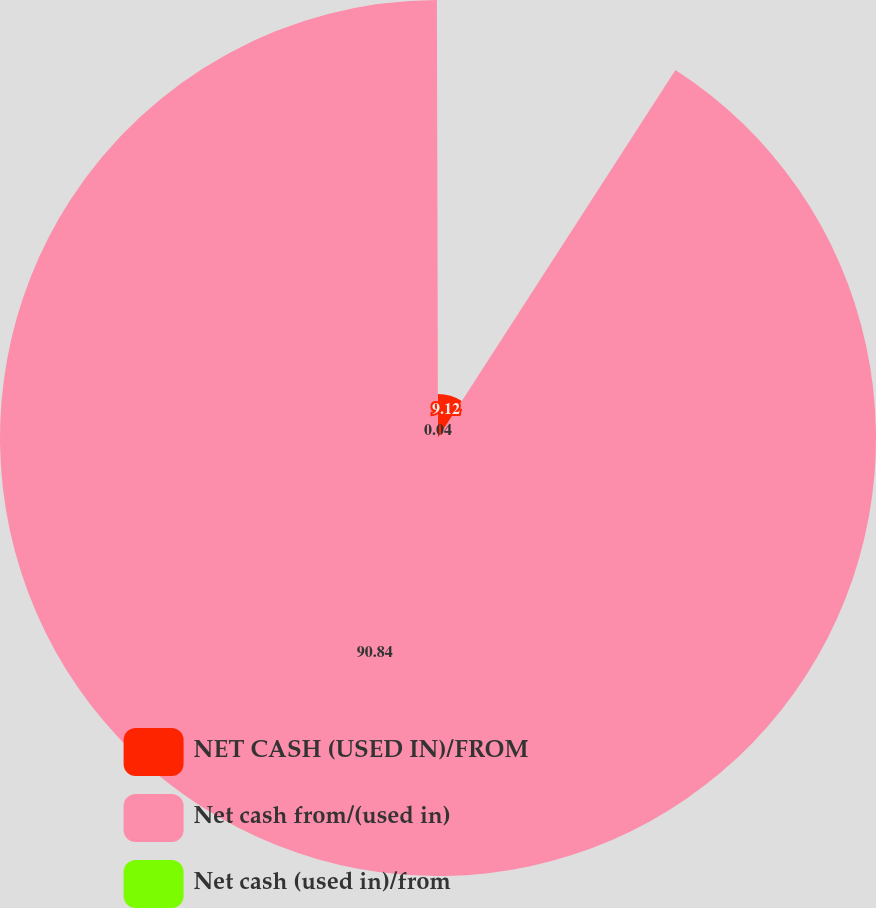Convert chart to OTSL. <chart><loc_0><loc_0><loc_500><loc_500><pie_chart><fcel>NET CASH (USED IN)/FROM<fcel>Net cash from/(used in)<fcel>Net cash (used in)/from<nl><fcel>9.12%<fcel>90.85%<fcel>0.04%<nl></chart> 